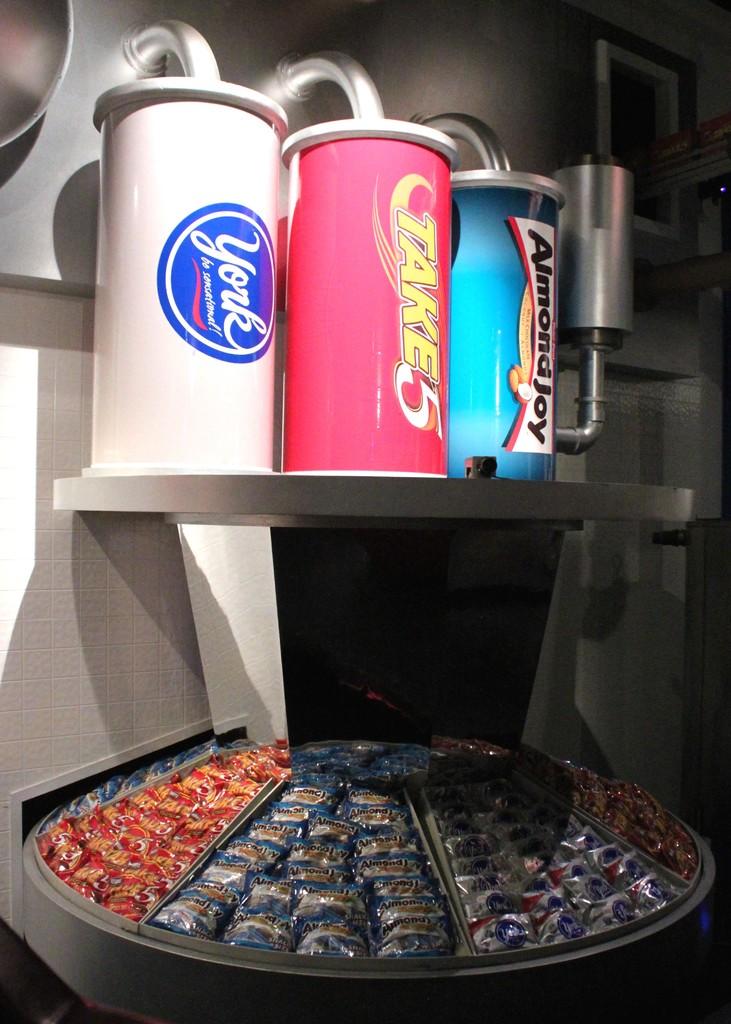Are these all candy?
Provide a succinct answer. Yes. 